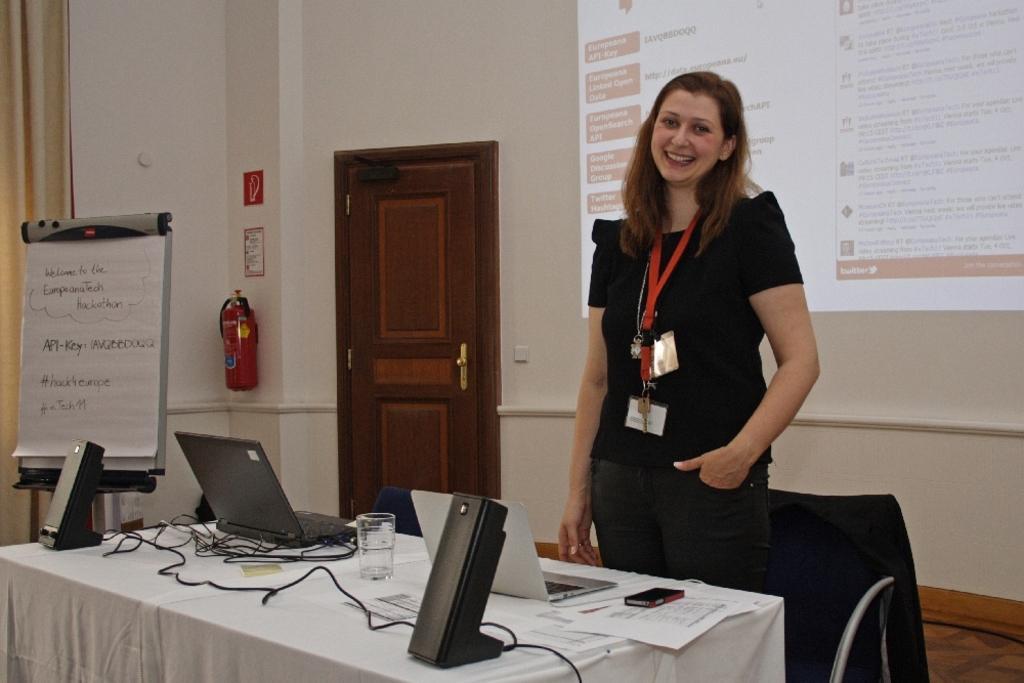In one or two sentences, can you explain what this image depicts? In this picture we can see women standing. There is a table. On the table we can see laptop,speaker, cable,glass,papers,mobile. We can see chair. In this background we can see screen and wall and there is a door. There is a board. 